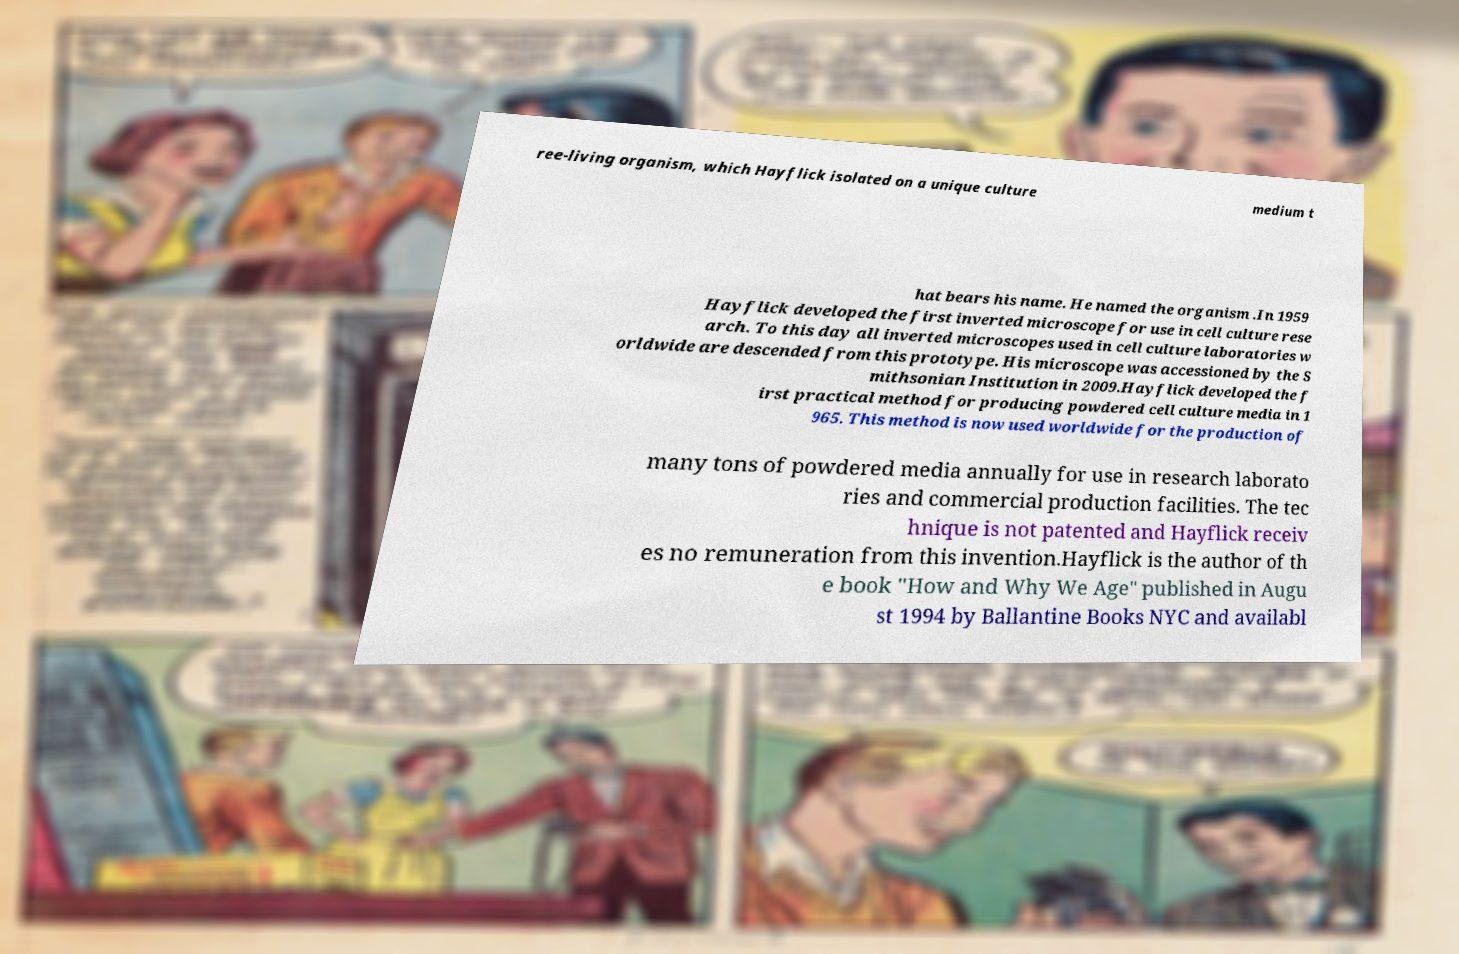What messages or text are displayed in this image? I need them in a readable, typed format. ree-living organism, which Hayflick isolated on a unique culture medium t hat bears his name. He named the organism .In 1959 Hayflick developed the first inverted microscope for use in cell culture rese arch. To this day all inverted microscopes used in cell culture laboratories w orldwide are descended from this prototype. His microscope was accessioned by the S mithsonian Institution in 2009.Hayflick developed the f irst practical method for producing powdered cell culture media in 1 965. This method is now used worldwide for the production of many tons of powdered media annually for use in research laborato ries and commercial production facilities. The tec hnique is not patented and Hayflick receiv es no remuneration from this invention.Hayflick is the author of th e book "How and Why We Age" published in Augu st 1994 by Ballantine Books NYC and availabl 